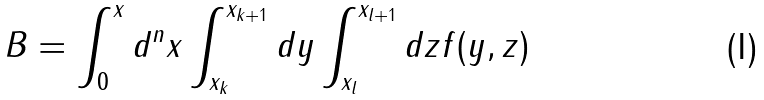<formula> <loc_0><loc_0><loc_500><loc_500>B = \int _ { 0 } ^ { x } d ^ { n } x \int _ { x _ { k } } ^ { x _ { k + 1 } } d y \int _ { x _ { l } } ^ { x _ { l + 1 } } d z f ( y , z )</formula> 